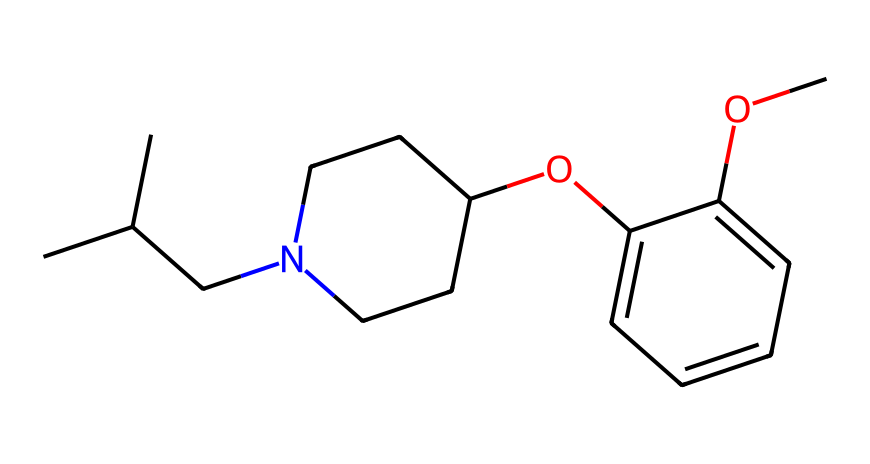What is the molecular formula of this chemical? To determine the molecular formula, count the number of each type of atom in the SMILES representation. From the chemical, we identify 15 carbon atoms, 21 hydrogen atoms, 1 nitrogen atom, and 3 oxygen atoms. Therefore, the molecular formula is C15H21N3O3.
Answer: C15H21N3O3 How many rings are present in the structure? By analyzing the chemical structure in the SMILES notation, we can identify that there are two rings indicated by the numbers ‘1’ and ‘2’. The first ring is between the nitrogen-containing cycloalkane, and the second is made up of aromatic carbon atoms.
Answer: 2 What type of drug is this compound classified as? Given the structure is an organic compound with a nitrogen atom and certain functional groups consistent with muscle relaxants, it can be classified as a muscle relaxant.
Answer: muscle relaxant Which functional groups are present in this chemical? Upon examining the SMILES representation, we observe the presence of an ether (due to the -O- link), and the presence of an aromatic ring indicates a phenolic group. There are also aliphatic amines due to the nitrogen.
Answer: ether, aromatic, amine What is the significance of the nitrogen atom in this structure? The nitrogen atom suggests that this compound is likely to have pharmacological properties, often associated with muscle relaxants. It contributes to the basicity of the compound which can affect drug-receptor interactions.
Answer: pharmacological properties 